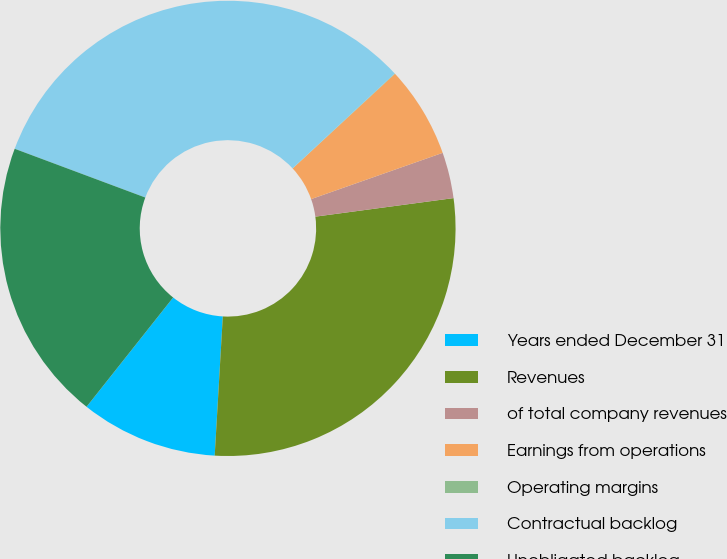Convert chart. <chart><loc_0><loc_0><loc_500><loc_500><pie_chart><fcel>Years ended December 31<fcel>Revenues<fcel>of total company revenues<fcel>Earnings from operations<fcel>Operating margins<fcel>Contractual backlog<fcel>Unobligated backlog<nl><fcel>9.74%<fcel>28.05%<fcel>3.26%<fcel>6.5%<fcel>0.03%<fcel>32.4%<fcel>20.02%<nl></chart> 